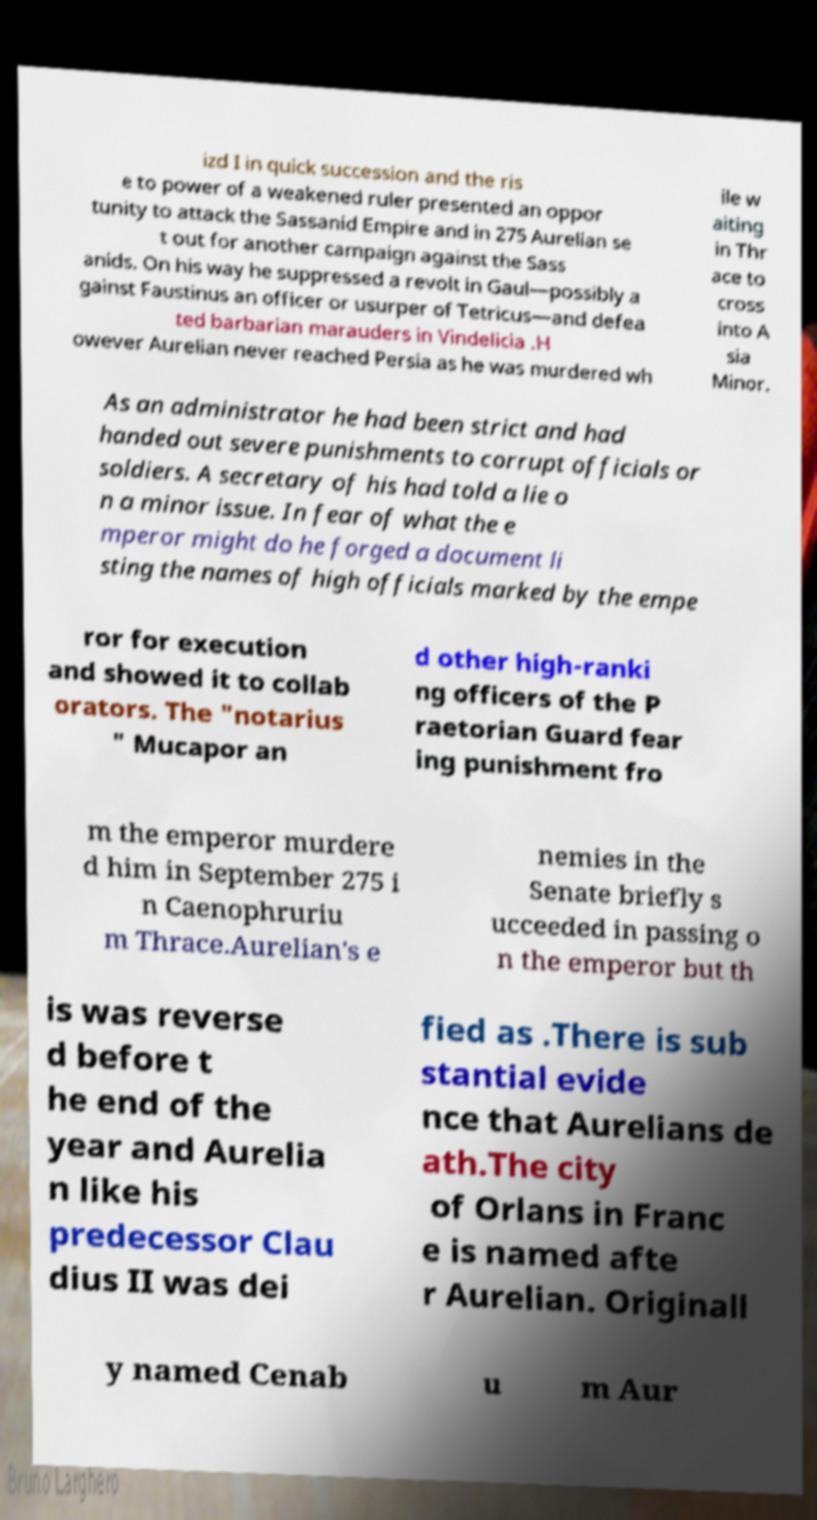Please identify and transcribe the text found in this image. izd I in quick succession and the ris e to power of a weakened ruler presented an oppor tunity to attack the Sassanid Empire and in 275 Aurelian se t out for another campaign against the Sass anids. On his way he suppressed a revolt in Gaul—possibly a gainst Faustinus an officer or usurper of Tetricus—and defea ted barbarian marauders in Vindelicia .H owever Aurelian never reached Persia as he was murdered wh ile w aiting in Thr ace to cross into A sia Minor. As an administrator he had been strict and had handed out severe punishments to corrupt officials or soldiers. A secretary of his had told a lie o n a minor issue. In fear of what the e mperor might do he forged a document li sting the names of high officials marked by the empe ror for execution and showed it to collab orators. The "notarius " Mucapor an d other high-ranki ng officers of the P raetorian Guard fear ing punishment fro m the emperor murdere d him in September 275 i n Caenophruriu m Thrace.Aurelian's e nemies in the Senate briefly s ucceeded in passing o n the emperor but th is was reverse d before t he end of the year and Aurelia n like his predecessor Clau dius II was dei fied as .There is sub stantial evide nce that Aurelians de ath.The city of Orlans in Franc e is named afte r Aurelian. Originall y named Cenab u m Aur 